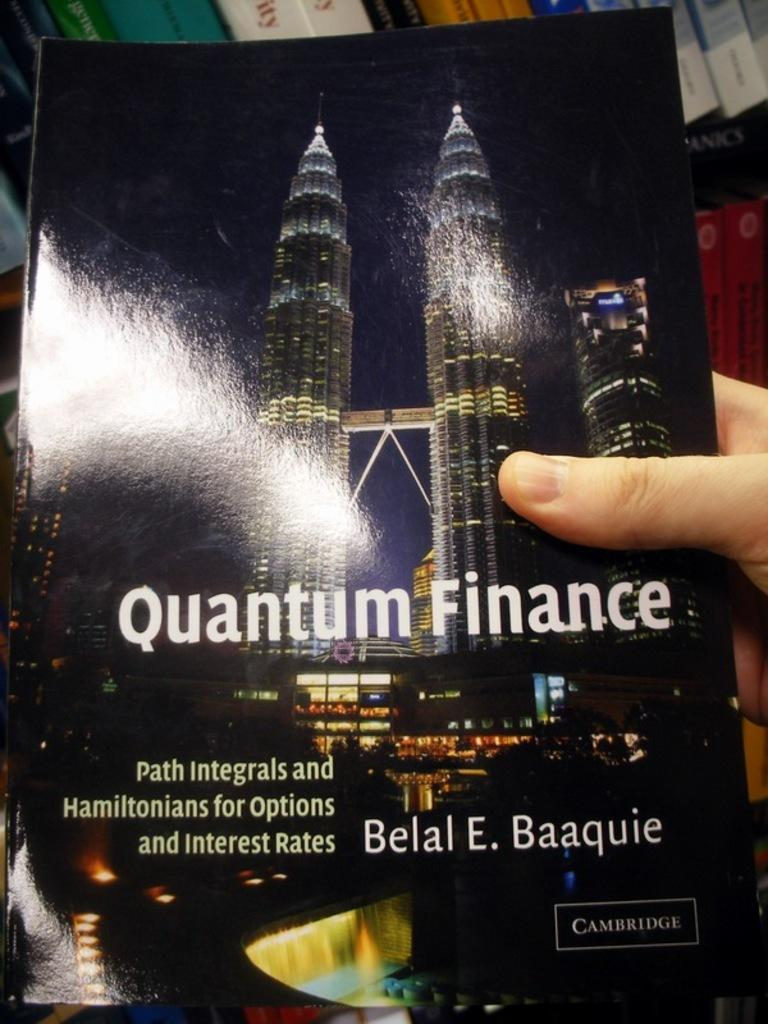<image>
Share a concise interpretation of the image provided. A hand holding a book titled Quantum Finance. 